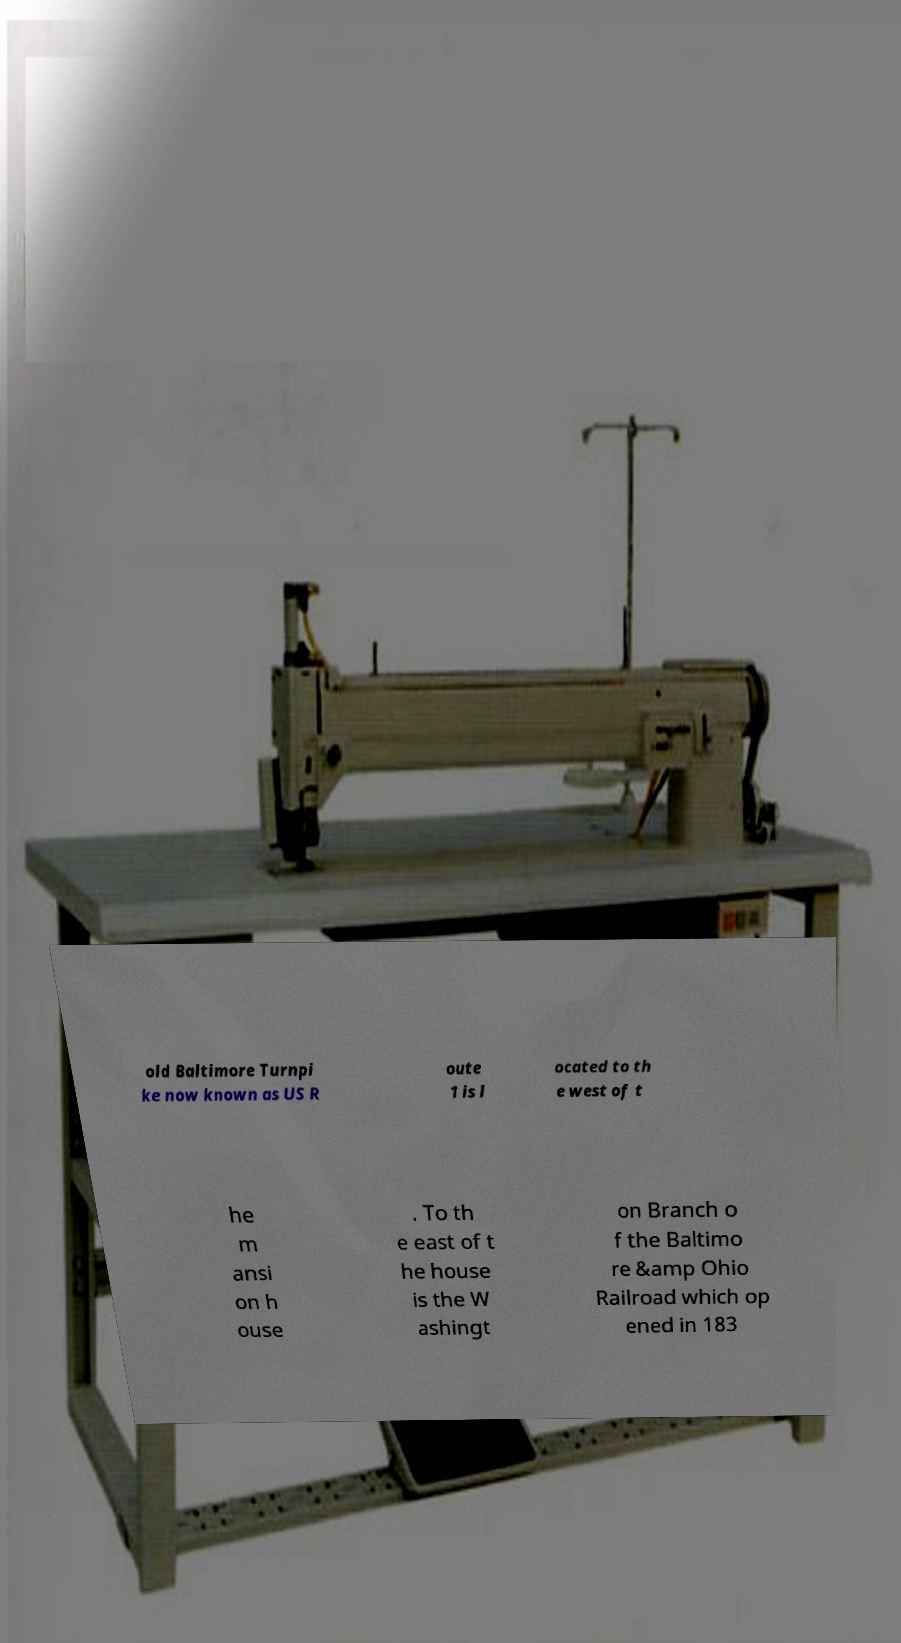For documentation purposes, I need the text within this image transcribed. Could you provide that? old Baltimore Turnpi ke now known as US R oute 1 is l ocated to th e west of t he m ansi on h ouse . To th e east of t he house is the W ashingt on Branch o f the Baltimo re &amp Ohio Railroad which op ened in 183 